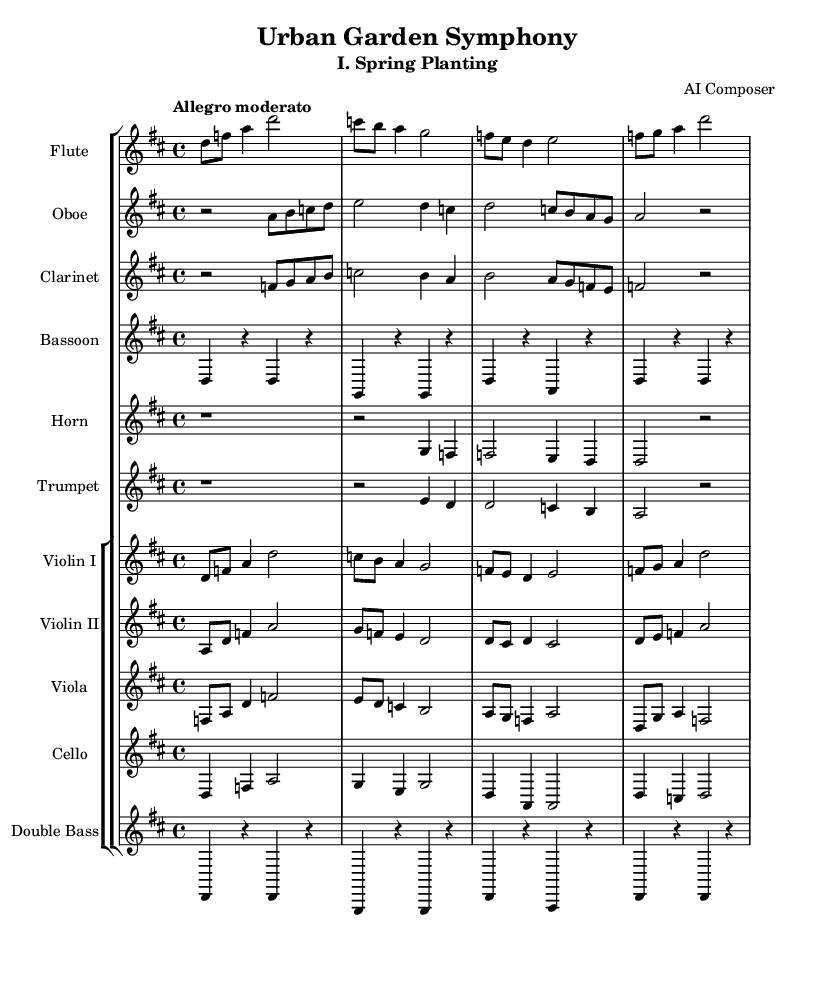what is the key signature of this music? The key signature shown in the clef indicates the presence of two sharps, which identifies D major as the key.
Answer: D major what is the time signature of this music? The time signature is indicated at the beginning of the score, showing 4 beats per measure, which is represented as 4/4.
Answer: 4/4 what is the tempo marking for this symphony? The tempo marking at the beginning indicates "Allegro moderato," suggesting a moderate fast speed.
Answer: Allegro moderato how many instruments are featured in this symphony? By counting the individual staff labels, there are ten distinct instruments listed in the score.
Answer: Ten what is the pattern of the first violin melody in the first measure? The first measure of the first violin shows the notes are d, f, and a, creating a rising melodic pattern.
Answer: d, f, a which instrument plays a sustaining note in the second measure? Looking closely at the second measure, the bassoon has a rest corresponding with the reinforcing line from the double bass, indicating it sustains a note.
Answer: Bassoon how does the theme of growth appear in the orchestration? Analyzing the orchestration, the alternating instrument parts create a layered texture that symbolizes the harmony and complexity of nature's growth, reflected through interplaying melodies.
Answer: Interplaying melodies 